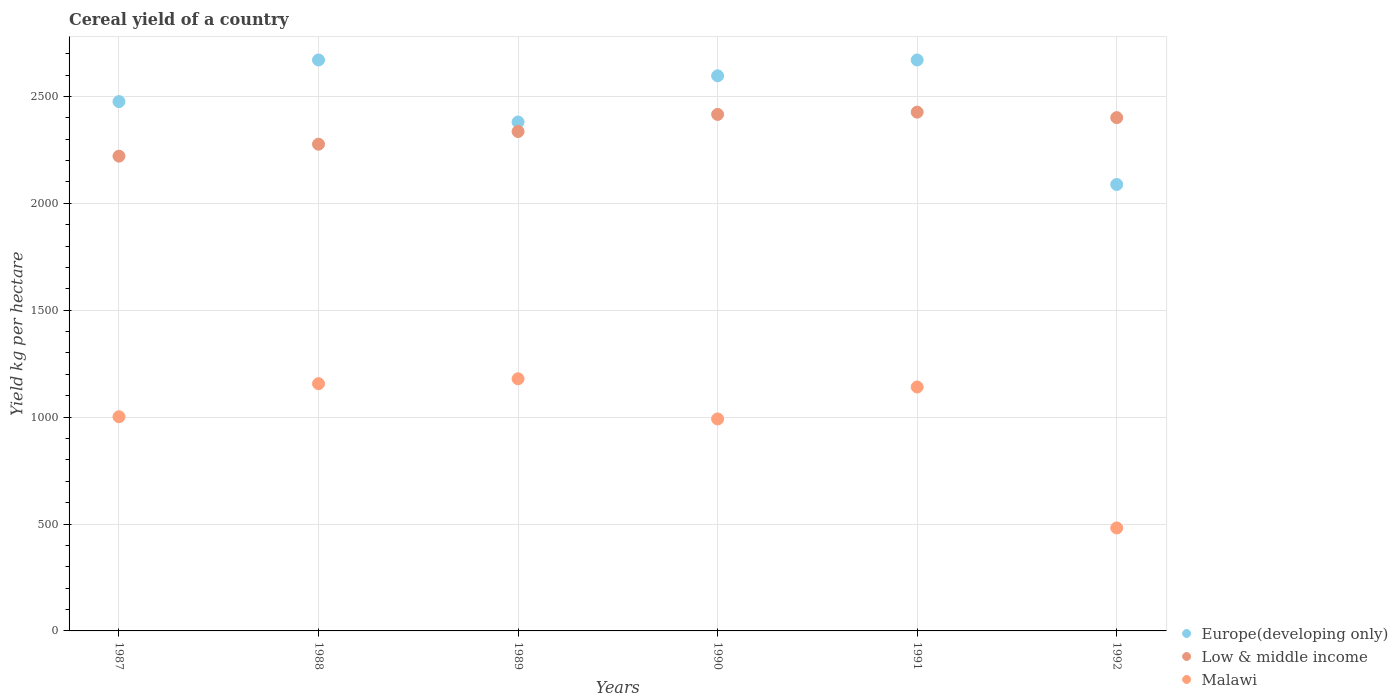What is the total cereal yield in Low & middle income in 1987?
Your answer should be very brief. 2220.65. Across all years, what is the maximum total cereal yield in Malawi?
Offer a terse response. 1179.42. Across all years, what is the minimum total cereal yield in Europe(developing only)?
Offer a very short reply. 2088.12. In which year was the total cereal yield in Malawi minimum?
Your answer should be very brief. 1992. What is the total total cereal yield in Europe(developing only) in the graph?
Offer a very short reply. 1.49e+04. What is the difference between the total cereal yield in Malawi in 1989 and that in 1992?
Provide a succinct answer. 697.83. What is the difference between the total cereal yield in Europe(developing only) in 1989 and the total cereal yield in Malawi in 1987?
Give a very brief answer. 1378.62. What is the average total cereal yield in Malawi per year?
Your answer should be very brief. 991.96. In the year 1989, what is the difference between the total cereal yield in Low & middle income and total cereal yield in Malawi?
Give a very brief answer. 1156.54. In how many years, is the total cereal yield in Malawi greater than 1400 kg per hectare?
Keep it short and to the point. 0. What is the ratio of the total cereal yield in Low & middle income in 1987 to that in 1989?
Your response must be concise. 0.95. Is the difference between the total cereal yield in Low & middle income in 1989 and 1990 greater than the difference between the total cereal yield in Malawi in 1989 and 1990?
Your answer should be compact. No. What is the difference between the highest and the second highest total cereal yield in Malawi?
Keep it short and to the point. 22.99. What is the difference between the highest and the lowest total cereal yield in Malawi?
Your answer should be very brief. 697.83. In how many years, is the total cereal yield in Europe(developing only) greater than the average total cereal yield in Europe(developing only) taken over all years?
Keep it short and to the point. 3. Is the sum of the total cereal yield in Malawi in 1987 and 1990 greater than the maximum total cereal yield in Europe(developing only) across all years?
Offer a terse response. No. Is the total cereal yield in Europe(developing only) strictly greater than the total cereal yield in Malawi over the years?
Provide a succinct answer. Yes. Is the total cereal yield in Malawi strictly less than the total cereal yield in Low & middle income over the years?
Make the answer very short. Yes. How many dotlines are there?
Your response must be concise. 3. What is the difference between two consecutive major ticks on the Y-axis?
Offer a very short reply. 500. Does the graph contain any zero values?
Make the answer very short. No. Where does the legend appear in the graph?
Offer a very short reply. Bottom right. What is the title of the graph?
Make the answer very short. Cereal yield of a country. Does "Guam" appear as one of the legend labels in the graph?
Make the answer very short. No. What is the label or title of the X-axis?
Your response must be concise. Years. What is the label or title of the Y-axis?
Keep it short and to the point. Yield kg per hectare. What is the Yield kg per hectare in Europe(developing only) in 1987?
Offer a terse response. 2475.85. What is the Yield kg per hectare of Low & middle income in 1987?
Provide a short and direct response. 2220.65. What is the Yield kg per hectare of Malawi in 1987?
Your response must be concise. 1001.8. What is the Yield kg per hectare of Europe(developing only) in 1988?
Your answer should be very brief. 2670.53. What is the Yield kg per hectare of Low & middle income in 1988?
Make the answer very short. 2276.57. What is the Yield kg per hectare in Malawi in 1988?
Provide a short and direct response. 1156.43. What is the Yield kg per hectare in Europe(developing only) in 1989?
Offer a very short reply. 2380.42. What is the Yield kg per hectare in Low & middle income in 1989?
Your response must be concise. 2335.96. What is the Yield kg per hectare of Malawi in 1989?
Your answer should be compact. 1179.42. What is the Yield kg per hectare of Europe(developing only) in 1990?
Your response must be concise. 2596.54. What is the Yield kg per hectare in Low & middle income in 1990?
Provide a short and direct response. 2415.92. What is the Yield kg per hectare of Malawi in 1990?
Provide a succinct answer. 991.55. What is the Yield kg per hectare of Europe(developing only) in 1991?
Your response must be concise. 2670.49. What is the Yield kg per hectare in Low & middle income in 1991?
Offer a very short reply. 2426.55. What is the Yield kg per hectare in Malawi in 1991?
Offer a very short reply. 1140.96. What is the Yield kg per hectare in Europe(developing only) in 1992?
Give a very brief answer. 2088.12. What is the Yield kg per hectare in Low & middle income in 1992?
Ensure brevity in your answer.  2400.86. What is the Yield kg per hectare of Malawi in 1992?
Your response must be concise. 481.6. Across all years, what is the maximum Yield kg per hectare in Europe(developing only)?
Your answer should be compact. 2670.53. Across all years, what is the maximum Yield kg per hectare in Low & middle income?
Make the answer very short. 2426.55. Across all years, what is the maximum Yield kg per hectare in Malawi?
Provide a succinct answer. 1179.42. Across all years, what is the minimum Yield kg per hectare in Europe(developing only)?
Offer a terse response. 2088.12. Across all years, what is the minimum Yield kg per hectare of Low & middle income?
Provide a short and direct response. 2220.65. Across all years, what is the minimum Yield kg per hectare in Malawi?
Make the answer very short. 481.6. What is the total Yield kg per hectare of Europe(developing only) in the graph?
Your answer should be compact. 1.49e+04. What is the total Yield kg per hectare of Low & middle income in the graph?
Offer a very short reply. 1.41e+04. What is the total Yield kg per hectare in Malawi in the graph?
Ensure brevity in your answer.  5951.77. What is the difference between the Yield kg per hectare in Europe(developing only) in 1987 and that in 1988?
Your answer should be very brief. -194.68. What is the difference between the Yield kg per hectare of Low & middle income in 1987 and that in 1988?
Offer a very short reply. -55.92. What is the difference between the Yield kg per hectare in Malawi in 1987 and that in 1988?
Your answer should be compact. -154.63. What is the difference between the Yield kg per hectare in Europe(developing only) in 1987 and that in 1989?
Provide a short and direct response. 95.43. What is the difference between the Yield kg per hectare in Low & middle income in 1987 and that in 1989?
Provide a succinct answer. -115.31. What is the difference between the Yield kg per hectare in Malawi in 1987 and that in 1989?
Keep it short and to the point. -177.62. What is the difference between the Yield kg per hectare of Europe(developing only) in 1987 and that in 1990?
Give a very brief answer. -120.69. What is the difference between the Yield kg per hectare of Low & middle income in 1987 and that in 1990?
Ensure brevity in your answer.  -195.27. What is the difference between the Yield kg per hectare of Malawi in 1987 and that in 1990?
Your answer should be compact. 10.26. What is the difference between the Yield kg per hectare in Europe(developing only) in 1987 and that in 1991?
Provide a succinct answer. -194.64. What is the difference between the Yield kg per hectare of Low & middle income in 1987 and that in 1991?
Make the answer very short. -205.9. What is the difference between the Yield kg per hectare of Malawi in 1987 and that in 1991?
Keep it short and to the point. -139.16. What is the difference between the Yield kg per hectare of Europe(developing only) in 1987 and that in 1992?
Offer a very short reply. 387.73. What is the difference between the Yield kg per hectare of Low & middle income in 1987 and that in 1992?
Offer a very short reply. -180.21. What is the difference between the Yield kg per hectare of Malawi in 1987 and that in 1992?
Your answer should be very brief. 520.21. What is the difference between the Yield kg per hectare in Europe(developing only) in 1988 and that in 1989?
Provide a short and direct response. 290.11. What is the difference between the Yield kg per hectare of Low & middle income in 1988 and that in 1989?
Your response must be concise. -59.39. What is the difference between the Yield kg per hectare of Malawi in 1988 and that in 1989?
Offer a very short reply. -22.99. What is the difference between the Yield kg per hectare of Europe(developing only) in 1988 and that in 1990?
Ensure brevity in your answer.  74. What is the difference between the Yield kg per hectare of Low & middle income in 1988 and that in 1990?
Your response must be concise. -139.35. What is the difference between the Yield kg per hectare of Malawi in 1988 and that in 1990?
Offer a terse response. 164.89. What is the difference between the Yield kg per hectare in Europe(developing only) in 1988 and that in 1991?
Provide a short and direct response. 0.04. What is the difference between the Yield kg per hectare of Low & middle income in 1988 and that in 1991?
Offer a very short reply. -149.98. What is the difference between the Yield kg per hectare of Malawi in 1988 and that in 1991?
Offer a very short reply. 15.47. What is the difference between the Yield kg per hectare of Europe(developing only) in 1988 and that in 1992?
Offer a very short reply. 582.41. What is the difference between the Yield kg per hectare in Low & middle income in 1988 and that in 1992?
Make the answer very short. -124.29. What is the difference between the Yield kg per hectare in Malawi in 1988 and that in 1992?
Make the answer very short. 674.84. What is the difference between the Yield kg per hectare in Europe(developing only) in 1989 and that in 1990?
Your answer should be very brief. -216.11. What is the difference between the Yield kg per hectare in Low & middle income in 1989 and that in 1990?
Make the answer very short. -79.96. What is the difference between the Yield kg per hectare of Malawi in 1989 and that in 1990?
Your answer should be very brief. 187.88. What is the difference between the Yield kg per hectare of Europe(developing only) in 1989 and that in 1991?
Your answer should be very brief. -290.07. What is the difference between the Yield kg per hectare in Low & middle income in 1989 and that in 1991?
Make the answer very short. -90.59. What is the difference between the Yield kg per hectare of Malawi in 1989 and that in 1991?
Your answer should be very brief. 38.46. What is the difference between the Yield kg per hectare of Europe(developing only) in 1989 and that in 1992?
Keep it short and to the point. 292.3. What is the difference between the Yield kg per hectare in Low & middle income in 1989 and that in 1992?
Offer a very short reply. -64.9. What is the difference between the Yield kg per hectare of Malawi in 1989 and that in 1992?
Keep it short and to the point. 697.83. What is the difference between the Yield kg per hectare in Europe(developing only) in 1990 and that in 1991?
Offer a very short reply. -73.96. What is the difference between the Yield kg per hectare of Low & middle income in 1990 and that in 1991?
Make the answer very short. -10.63. What is the difference between the Yield kg per hectare in Malawi in 1990 and that in 1991?
Make the answer very short. -149.41. What is the difference between the Yield kg per hectare of Europe(developing only) in 1990 and that in 1992?
Offer a very short reply. 508.41. What is the difference between the Yield kg per hectare of Low & middle income in 1990 and that in 1992?
Your answer should be very brief. 15.06. What is the difference between the Yield kg per hectare of Malawi in 1990 and that in 1992?
Provide a succinct answer. 509.95. What is the difference between the Yield kg per hectare of Europe(developing only) in 1991 and that in 1992?
Provide a succinct answer. 582.37. What is the difference between the Yield kg per hectare in Low & middle income in 1991 and that in 1992?
Give a very brief answer. 25.69. What is the difference between the Yield kg per hectare of Malawi in 1991 and that in 1992?
Give a very brief answer. 659.36. What is the difference between the Yield kg per hectare of Europe(developing only) in 1987 and the Yield kg per hectare of Low & middle income in 1988?
Offer a very short reply. 199.28. What is the difference between the Yield kg per hectare in Europe(developing only) in 1987 and the Yield kg per hectare in Malawi in 1988?
Offer a terse response. 1319.42. What is the difference between the Yield kg per hectare in Low & middle income in 1987 and the Yield kg per hectare in Malawi in 1988?
Your answer should be compact. 1064.22. What is the difference between the Yield kg per hectare of Europe(developing only) in 1987 and the Yield kg per hectare of Low & middle income in 1989?
Provide a succinct answer. 139.89. What is the difference between the Yield kg per hectare of Europe(developing only) in 1987 and the Yield kg per hectare of Malawi in 1989?
Offer a very short reply. 1296.43. What is the difference between the Yield kg per hectare of Low & middle income in 1987 and the Yield kg per hectare of Malawi in 1989?
Your answer should be very brief. 1041.23. What is the difference between the Yield kg per hectare of Europe(developing only) in 1987 and the Yield kg per hectare of Low & middle income in 1990?
Your answer should be compact. 59.93. What is the difference between the Yield kg per hectare of Europe(developing only) in 1987 and the Yield kg per hectare of Malawi in 1990?
Make the answer very short. 1484.3. What is the difference between the Yield kg per hectare in Low & middle income in 1987 and the Yield kg per hectare in Malawi in 1990?
Your answer should be very brief. 1229.1. What is the difference between the Yield kg per hectare in Europe(developing only) in 1987 and the Yield kg per hectare in Low & middle income in 1991?
Offer a terse response. 49.3. What is the difference between the Yield kg per hectare in Europe(developing only) in 1987 and the Yield kg per hectare in Malawi in 1991?
Provide a short and direct response. 1334.89. What is the difference between the Yield kg per hectare in Low & middle income in 1987 and the Yield kg per hectare in Malawi in 1991?
Offer a very short reply. 1079.69. What is the difference between the Yield kg per hectare of Europe(developing only) in 1987 and the Yield kg per hectare of Low & middle income in 1992?
Make the answer very short. 74.99. What is the difference between the Yield kg per hectare in Europe(developing only) in 1987 and the Yield kg per hectare in Malawi in 1992?
Give a very brief answer. 1994.25. What is the difference between the Yield kg per hectare in Low & middle income in 1987 and the Yield kg per hectare in Malawi in 1992?
Your response must be concise. 1739.05. What is the difference between the Yield kg per hectare of Europe(developing only) in 1988 and the Yield kg per hectare of Low & middle income in 1989?
Your response must be concise. 334.57. What is the difference between the Yield kg per hectare in Europe(developing only) in 1988 and the Yield kg per hectare in Malawi in 1989?
Your response must be concise. 1491.11. What is the difference between the Yield kg per hectare in Low & middle income in 1988 and the Yield kg per hectare in Malawi in 1989?
Your answer should be very brief. 1097.14. What is the difference between the Yield kg per hectare of Europe(developing only) in 1988 and the Yield kg per hectare of Low & middle income in 1990?
Provide a succinct answer. 254.61. What is the difference between the Yield kg per hectare in Europe(developing only) in 1988 and the Yield kg per hectare in Malawi in 1990?
Make the answer very short. 1678.99. What is the difference between the Yield kg per hectare in Low & middle income in 1988 and the Yield kg per hectare in Malawi in 1990?
Ensure brevity in your answer.  1285.02. What is the difference between the Yield kg per hectare of Europe(developing only) in 1988 and the Yield kg per hectare of Low & middle income in 1991?
Your response must be concise. 243.98. What is the difference between the Yield kg per hectare of Europe(developing only) in 1988 and the Yield kg per hectare of Malawi in 1991?
Provide a succinct answer. 1529.57. What is the difference between the Yield kg per hectare in Low & middle income in 1988 and the Yield kg per hectare in Malawi in 1991?
Provide a succinct answer. 1135.61. What is the difference between the Yield kg per hectare of Europe(developing only) in 1988 and the Yield kg per hectare of Low & middle income in 1992?
Provide a short and direct response. 269.67. What is the difference between the Yield kg per hectare of Europe(developing only) in 1988 and the Yield kg per hectare of Malawi in 1992?
Your response must be concise. 2188.94. What is the difference between the Yield kg per hectare of Low & middle income in 1988 and the Yield kg per hectare of Malawi in 1992?
Your answer should be very brief. 1794.97. What is the difference between the Yield kg per hectare of Europe(developing only) in 1989 and the Yield kg per hectare of Low & middle income in 1990?
Ensure brevity in your answer.  -35.49. What is the difference between the Yield kg per hectare of Europe(developing only) in 1989 and the Yield kg per hectare of Malawi in 1990?
Provide a succinct answer. 1388.88. What is the difference between the Yield kg per hectare in Low & middle income in 1989 and the Yield kg per hectare in Malawi in 1990?
Your answer should be compact. 1344.41. What is the difference between the Yield kg per hectare of Europe(developing only) in 1989 and the Yield kg per hectare of Low & middle income in 1991?
Your answer should be very brief. -46.13. What is the difference between the Yield kg per hectare of Europe(developing only) in 1989 and the Yield kg per hectare of Malawi in 1991?
Give a very brief answer. 1239.46. What is the difference between the Yield kg per hectare of Low & middle income in 1989 and the Yield kg per hectare of Malawi in 1991?
Your answer should be very brief. 1195. What is the difference between the Yield kg per hectare of Europe(developing only) in 1989 and the Yield kg per hectare of Low & middle income in 1992?
Offer a very short reply. -20.43. What is the difference between the Yield kg per hectare of Europe(developing only) in 1989 and the Yield kg per hectare of Malawi in 1992?
Ensure brevity in your answer.  1898.83. What is the difference between the Yield kg per hectare in Low & middle income in 1989 and the Yield kg per hectare in Malawi in 1992?
Provide a short and direct response. 1854.36. What is the difference between the Yield kg per hectare of Europe(developing only) in 1990 and the Yield kg per hectare of Low & middle income in 1991?
Keep it short and to the point. 169.98. What is the difference between the Yield kg per hectare in Europe(developing only) in 1990 and the Yield kg per hectare in Malawi in 1991?
Offer a terse response. 1455.58. What is the difference between the Yield kg per hectare in Low & middle income in 1990 and the Yield kg per hectare in Malawi in 1991?
Ensure brevity in your answer.  1274.96. What is the difference between the Yield kg per hectare of Europe(developing only) in 1990 and the Yield kg per hectare of Low & middle income in 1992?
Keep it short and to the point. 195.68. What is the difference between the Yield kg per hectare of Europe(developing only) in 1990 and the Yield kg per hectare of Malawi in 1992?
Provide a succinct answer. 2114.94. What is the difference between the Yield kg per hectare of Low & middle income in 1990 and the Yield kg per hectare of Malawi in 1992?
Keep it short and to the point. 1934.32. What is the difference between the Yield kg per hectare of Europe(developing only) in 1991 and the Yield kg per hectare of Low & middle income in 1992?
Your response must be concise. 269.64. What is the difference between the Yield kg per hectare of Europe(developing only) in 1991 and the Yield kg per hectare of Malawi in 1992?
Provide a short and direct response. 2188.9. What is the difference between the Yield kg per hectare of Low & middle income in 1991 and the Yield kg per hectare of Malawi in 1992?
Your response must be concise. 1944.96. What is the average Yield kg per hectare in Europe(developing only) per year?
Provide a succinct answer. 2480.33. What is the average Yield kg per hectare of Low & middle income per year?
Provide a short and direct response. 2346.08. What is the average Yield kg per hectare of Malawi per year?
Keep it short and to the point. 991.96. In the year 1987, what is the difference between the Yield kg per hectare in Europe(developing only) and Yield kg per hectare in Low & middle income?
Provide a short and direct response. 255.2. In the year 1987, what is the difference between the Yield kg per hectare of Europe(developing only) and Yield kg per hectare of Malawi?
Your response must be concise. 1474.05. In the year 1987, what is the difference between the Yield kg per hectare of Low & middle income and Yield kg per hectare of Malawi?
Make the answer very short. 1218.84. In the year 1988, what is the difference between the Yield kg per hectare in Europe(developing only) and Yield kg per hectare in Low & middle income?
Your answer should be very brief. 393.97. In the year 1988, what is the difference between the Yield kg per hectare in Europe(developing only) and Yield kg per hectare in Malawi?
Your answer should be very brief. 1514.1. In the year 1988, what is the difference between the Yield kg per hectare of Low & middle income and Yield kg per hectare of Malawi?
Your response must be concise. 1120.14. In the year 1989, what is the difference between the Yield kg per hectare of Europe(developing only) and Yield kg per hectare of Low & middle income?
Make the answer very short. 44.46. In the year 1989, what is the difference between the Yield kg per hectare of Europe(developing only) and Yield kg per hectare of Malawi?
Give a very brief answer. 1201. In the year 1989, what is the difference between the Yield kg per hectare of Low & middle income and Yield kg per hectare of Malawi?
Your response must be concise. 1156.54. In the year 1990, what is the difference between the Yield kg per hectare of Europe(developing only) and Yield kg per hectare of Low & middle income?
Make the answer very short. 180.62. In the year 1990, what is the difference between the Yield kg per hectare in Europe(developing only) and Yield kg per hectare in Malawi?
Offer a very short reply. 1604.99. In the year 1990, what is the difference between the Yield kg per hectare of Low & middle income and Yield kg per hectare of Malawi?
Give a very brief answer. 1424.37. In the year 1991, what is the difference between the Yield kg per hectare of Europe(developing only) and Yield kg per hectare of Low & middle income?
Offer a terse response. 243.94. In the year 1991, what is the difference between the Yield kg per hectare of Europe(developing only) and Yield kg per hectare of Malawi?
Offer a very short reply. 1529.54. In the year 1991, what is the difference between the Yield kg per hectare of Low & middle income and Yield kg per hectare of Malawi?
Offer a terse response. 1285.59. In the year 1992, what is the difference between the Yield kg per hectare in Europe(developing only) and Yield kg per hectare in Low & middle income?
Offer a terse response. -312.74. In the year 1992, what is the difference between the Yield kg per hectare of Europe(developing only) and Yield kg per hectare of Malawi?
Your answer should be compact. 1606.52. In the year 1992, what is the difference between the Yield kg per hectare of Low & middle income and Yield kg per hectare of Malawi?
Ensure brevity in your answer.  1919.26. What is the ratio of the Yield kg per hectare of Europe(developing only) in 1987 to that in 1988?
Your answer should be compact. 0.93. What is the ratio of the Yield kg per hectare of Low & middle income in 1987 to that in 1988?
Your answer should be very brief. 0.98. What is the ratio of the Yield kg per hectare of Malawi in 1987 to that in 1988?
Make the answer very short. 0.87. What is the ratio of the Yield kg per hectare of Europe(developing only) in 1987 to that in 1989?
Provide a short and direct response. 1.04. What is the ratio of the Yield kg per hectare in Low & middle income in 1987 to that in 1989?
Offer a terse response. 0.95. What is the ratio of the Yield kg per hectare of Malawi in 1987 to that in 1989?
Ensure brevity in your answer.  0.85. What is the ratio of the Yield kg per hectare of Europe(developing only) in 1987 to that in 1990?
Your answer should be compact. 0.95. What is the ratio of the Yield kg per hectare in Low & middle income in 1987 to that in 1990?
Keep it short and to the point. 0.92. What is the ratio of the Yield kg per hectare of Malawi in 1987 to that in 1990?
Keep it short and to the point. 1.01. What is the ratio of the Yield kg per hectare of Europe(developing only) in 1987 to that in 1991?
Your response must be concise. 0.93. What is the ratio of the Yield kg per hectare in Low & middle income in 1987 to that in 1991?
Your answer should be very brief. 0.92. What is the ratio of the Yield kg per hectare in Malawi in 1987 to that in 1991?
Make the answer very short. 0.88. What is the ratio of the Yield kg per hectare of Europe(developing only) in 1987 to that in 1992?
Your answer should be very brief. 1.19. What is the ratio of the Yield kg per hectare in Low & middle income in 1987 to that in 1992?
Keep it short and to the point. 0.92. What is the ratio of the Yield kg per hectare in Malawi in 1987 to that in 1992?
Offer a very short reply. 2.08. What is the ratio of the Yield kg per hectare in Europe(developing only) in 1988 to that in 1989?
Your answer should be compact. 1.12. What is the ratio of the Yield kg per hectare of Low & middle income in 1988 to that in 1989?
Your response must be concise. 0.97. What is the ratio of the Yield kg per hectare in Malawi in 1988 to that in 1989?
Make the answer very short. 0.98. What is the ratio of the Yield kg per hectare in Europe(developing only) in 1988 to that in 1990?
Ensure brevity in your answer.  1.03. What is the ratio of the Yield kg per hectare in Low & middle income in 1988 to that in 1990?
Keep it short and to the point. 0.94. What is the ratio of the Yield kg per hectare of Malawi in 1988 to that in 1990?
Offer a very short reply. 1.17. What is the ratio of the Yield kg per hectare in Low & middle income in 1988 to that in 1991?
Provide a succinct answer. 0.94. What is the ratio of the Yield kg per hectare in Malawi in 1988 to that in 1991?
Offer a terse response. 1.01. What is the ratio of the Yield kg per hectare of Europe(developing only) in 1988 to that in 1992?
Your response must be concise. 1.28. What is the ratio of the Yield kg per hectare of Low & middle income in 1988 to that in 1992?
Your answer should be very brief. 0.95. What is the ratio of the Yield kg per hectare of Malawi in 1988 to that in 1992?
Your answer should be very brief. 2.4. What is the ratio of the Yield kg per hectare of Europe(developing only) in 1989 to that in 1990?
Keep it short and to the point. 0.92. What is the ratio of the Yield kg per hectare of Low & middle income in 1989 to that in 1990?
Make the answer very short. 0.97. What is the ratio of the Yield kg per hectare in Malawi in 1989 to that in 1990?
Your answer should be very brief. 1.19. What is the ratio of the Yield kg per hectare in Europe(developing only) in 1989 to that in 1991?
Ensure brevity in your answer.  0.89. What is the ratio of the Yield kg per hectare in Low & middle income in 1989 to that in 1991?
Offer a very short reply. 0.96. What is the ratio of the Yield kg per hectare in Malawi in 1989 to that in 1991?
Provide a succinct answer. 1.03. What is the ratio of the Yield kg per hectare of Europe(developing only) in 1989 to that in 1992?
Provide a succinct answer. 1.14. What is the ratio of the Yield kg per hectare of Malawi in 1989 to that in 1992?
Provide a short and direct response. 2.45. What is the ratio of the Yield kg per hectare in Europe(developing only) in 1990 to that in 1991?
Give a very brief answer. 0.97. What is the ratio of the Yield kg per hectare in Malawi in 1990 to that in 1991?
Your response must be concise. 0.87. What is the ratio of the Yield kg per hectare in Europe(developing only) in 1990 to that in 1992?
Provide a short and direct response. 1.24. What is the ratio of the Yield kg per hectare of Low & middle income in 1990 to that in 1992?
Give a very brief answer. 1.01. What is the ratio of the Yield kg per hectare of Malawi in 1990 to that in 1992?
Give a very brief answer. 2.06. What is the ratio of the Yield kg per hectare in Europe(developing only) in 1991 to that in 1992?
Make the answer very short. 1.28. What is the ratio of the Yield kg per hectare of Low & middle income in 1991 to that in 1992?
Ensure brevity in your answer.  1.01. What is the ratio of the Yield kg per hectare in Malawi in 1991 to that in 1992?
Offer a very short reply. 2.37. What is the difference between the highest and the second highest Yield kg per hectare of Europe(developing only)?
Provide a succinct answer. 0.04. What is the difference between the highest and the second highest Yield kg per hectare in Low & middle income?
Your answer should be very brief. 10.63. What is the difference between the highest and the second highest Yield kg per hectare of Malawi?
Ensure brevity in your answer.  22.99. What is the difference between the highest and the lowest Yield kg per hectare of Europe(developing only)?
Ensure brevity in your answer.  582.41. What is the difference between the highest and the lowest Yield kg per hectare of Low & middle income?
Offer a terse response. 205.9. What is the difference between the highest and the lowest Yield kg per hectare in Malawi?
Make the answer very short. 697.83. 